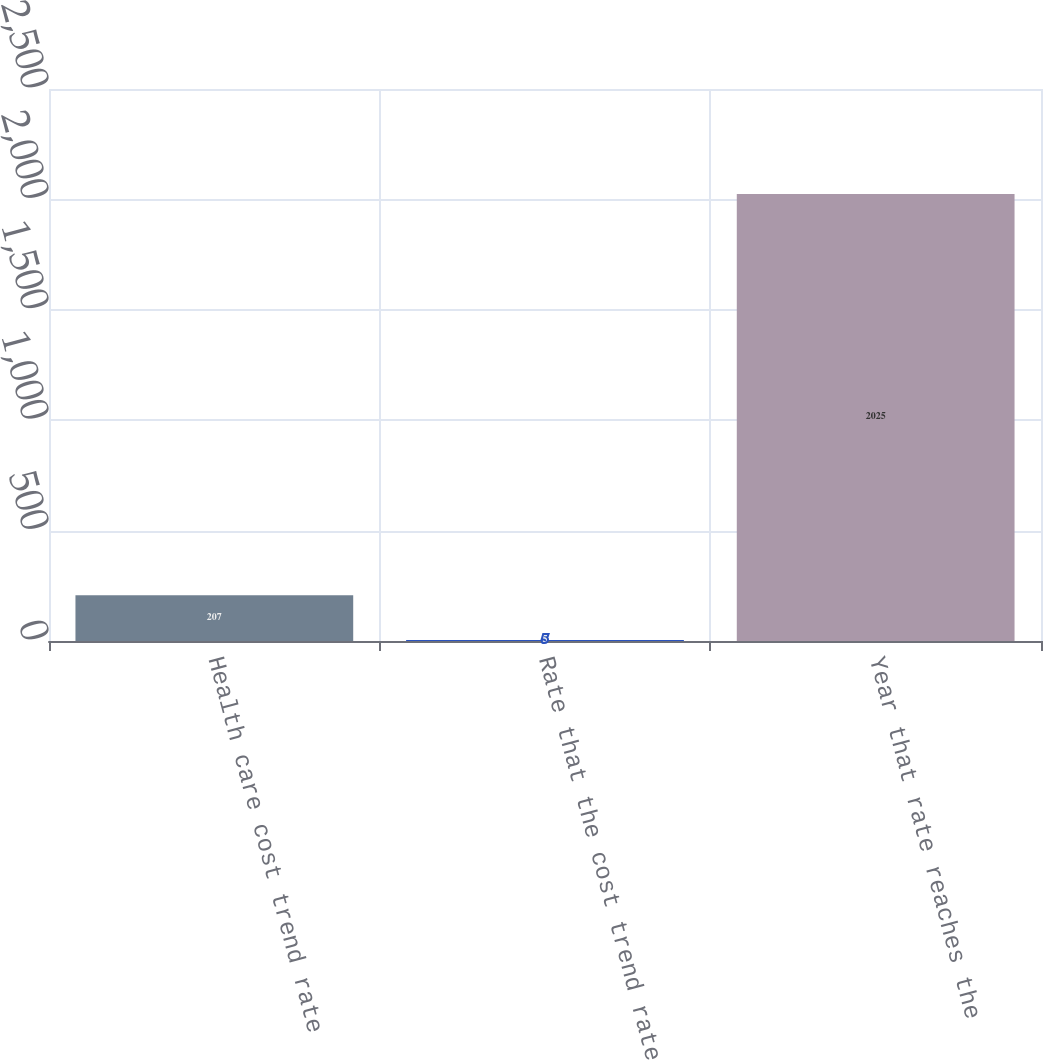Convert chart to OTSL. <chart><loc_0><loc_0><loc_500><loc_500><bar_chart><fcel>Health care cost trend rate<fcel>Rate that the cost trend rate<fcel>Year that rate reaches the<nl><fcel>207<fcel>5<fcel>2025<nl></chart> 